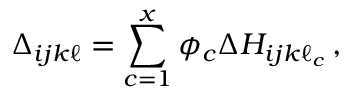Convert formula to latex. <formula><loc_0><loc_0><loc_500><loc_500>\Delta _ { i j k \ell } = \sum _ { c = 1 } ^ { x } \phi _ { c } \Delta H _ { i j k \ell _ { c } } \, ,</formula> 